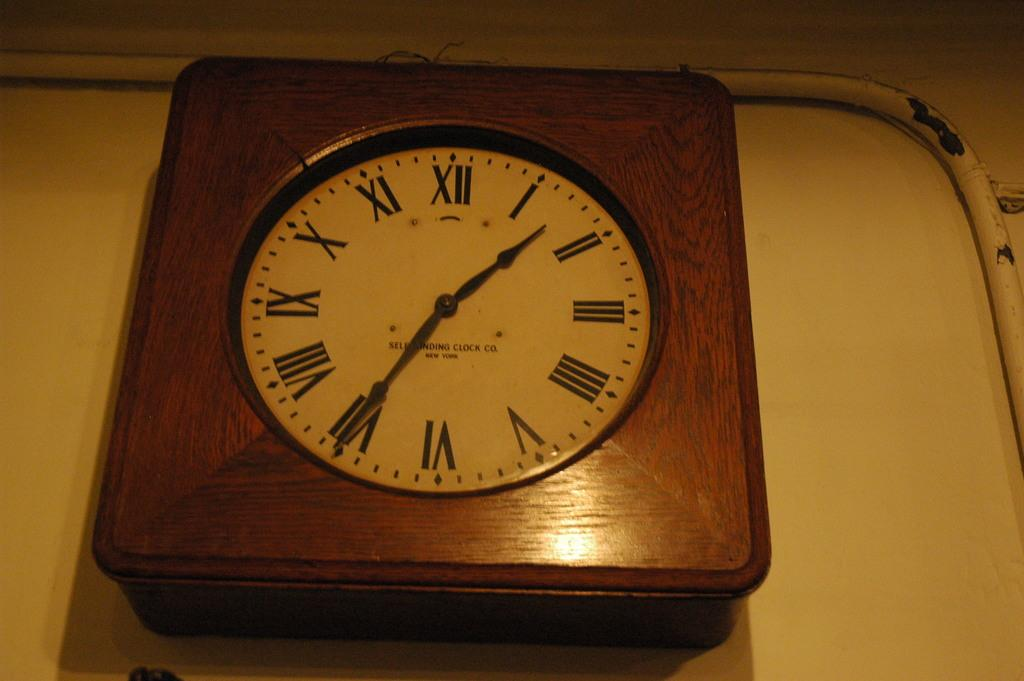<image>
Share a concise interpretation of the image provided. A clock with a square, wooden frame made by a clock company in New York. 